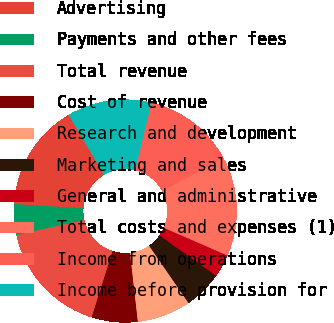Convert chart. <chart><loc_0><loc_0><loc_500><loc_500><pie_chart><fcel>Advertising<fcel>Payments and other fees<fcel>Total revenue<fcel>Cost of revenue<fcel>Research and development<fcel>Marketing and sales<fcel>General and administrative<fcel>Total costs and expenses (1)<fcel>Income from operations<fcel>Income before provision for<nl><fcel>15.55%<fcel>4.45%<fcel>16.67%<fcel>6.67%<fcel>7.78%<fcel>5.56%<fcel>3.33%<fcel>14.44%<fcel>13.33%<fcel>12.22%<nl></chart> 